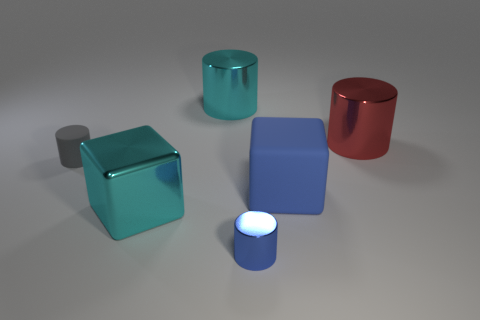Add 1 small red metallic things. How many objects exist? 7 Subtract all cylinders. How many objects are left? 2 Subtract all large gray cylinders. Subtract all red metal cylinders. How many objects are left? 5 Add 6 big shiny things. How many big shiny things are left? 9 Add 4 big cyan objects. How many big cyan objects exist? 6 Subtract 0 green cylinders. How many objects are left? 6 